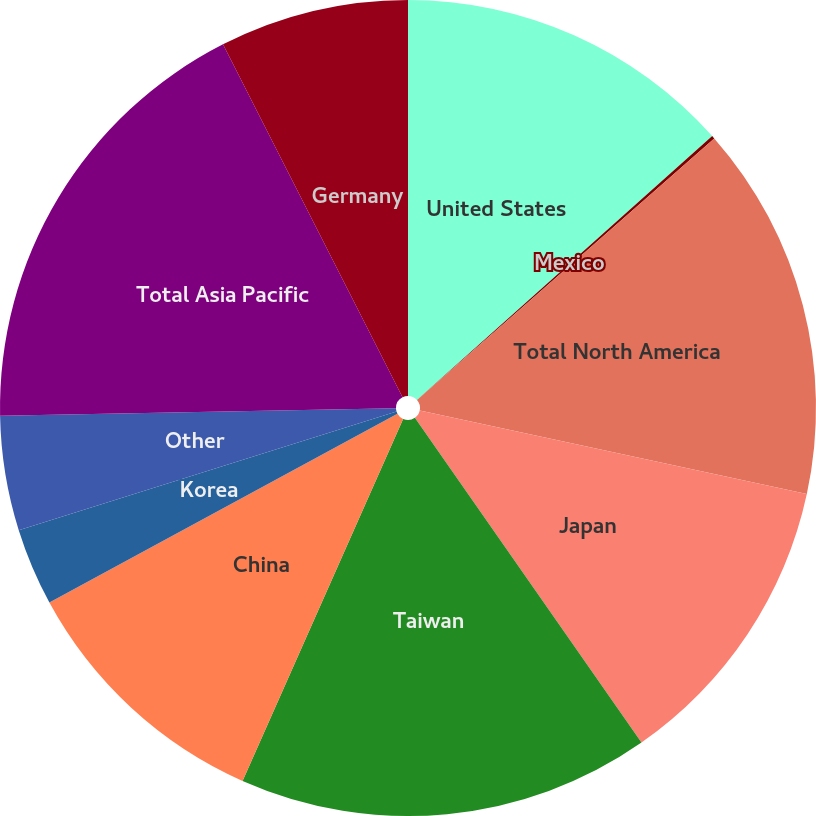Convert chart to OTSL. <chart><loc_0><loc_0><loc_500><loc_500><pie_chart><fcel>United States<fcel>Mexico<fcel>Total North America<fcel>Japan<fcel>Taiwan<fcel>China<fcel>Korea<fcel>Other<fcel>Total Asia Pacific<fcel>Germany<nl><fcel>13.39%<fcel>0.12%<fcel>14.87%<fcel>11.92%<fcel>16.34%<fcel>10.44%<fcel>3.07%<fcel>4.54%<fcel>17.81%<fcel>7.49%<nl></chart> 